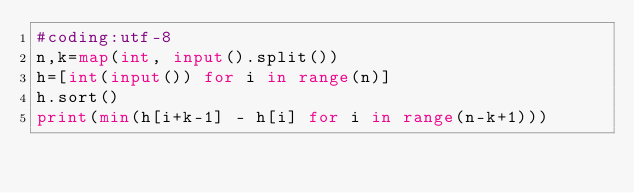<code> <loc_0><loc_0><loc_500><loc_500><_Python_>#coding:utf-8
n,k=map(int, input().split())
h=[int(input()) for i in range(n)]
h.sort()
print(min(h[i+k-1] - h[i] for i in range(n-k+1)))</code> 